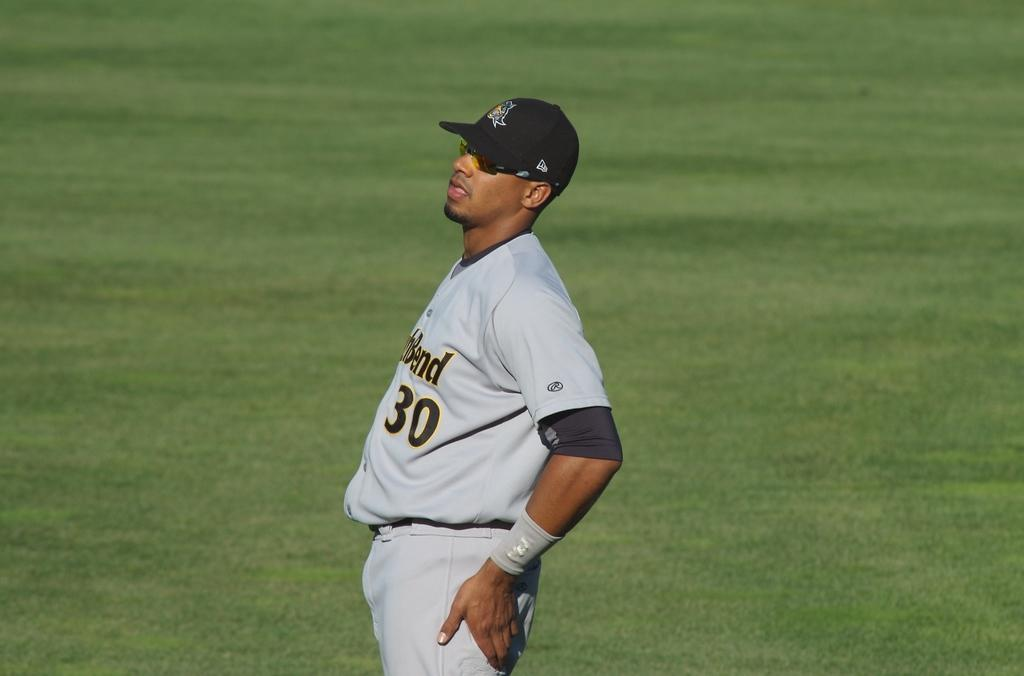Who is present in the image? There is a man in the image. What is the man wearing on his upper body? The man is wearing a white t-shirt. What type of headwear is the man wearing? The man is wearing a cap. In which direction is the man facing? The man is standing facing towards the left side. What can be seen in the background of the image? There is grass in the background of the image. What type of brass instrument is the man playing in the image? There is no brass instrument present in the image; the man is simply standing and facing towards the left side. 